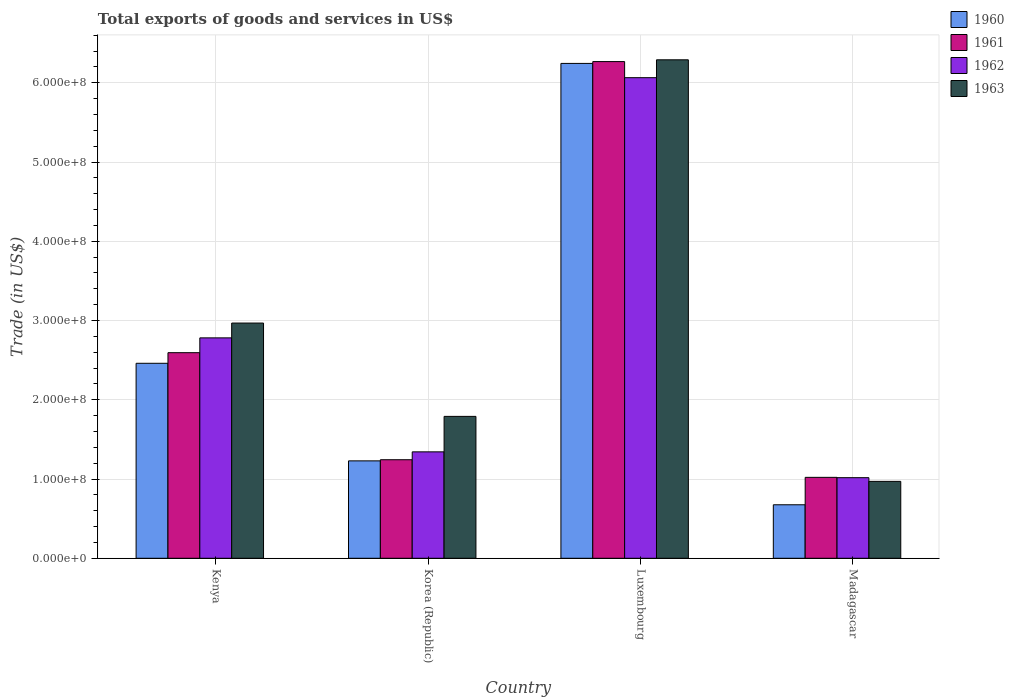How many groups of bars are there?
Ensure brevity in your answer.  4. Are the number of bars on each tick of the X-axis equal?
Make the answer very short. Yes. How many bars are there on the 1st tick from the right?
Provide a short and direct response. 4. What is the label of the 1st group of bars from the left?
Your answer should be very brief. Kenya. In how many cases, is the number of bars for a given country not equal to the number of legend labels?
Make the answer very short. 0. What is the total exports of goods and services in 1960 in Madagascar?
Ensure brevity in your answer.  6.75e+07. Across all countries, what is the maximum total exports of goods and services in 1962?
Provide a short and direct response. 6.06e+08. Across all countries, what is the minimum total exports of goods and services in 1960?
Provide a short and direct response. 6.75e+07. In which country was the total exports of goods and services in 1963 maximum?
Provide a succinct answer. Luxembourg. In which country was the total exports of goods and services in 1963 minimum?
Your answer should be very brief. Madagascar. What is the total total exports of goods and services in 1960 in the graph?
Give a very brief answer. 1.06e+09. What is the difference between the total exports of goods and services in 1962 in Korea (Republic) and that in Luxembourg?
Offer a very short reply. -4.72e+08. What is the difference between the total exports of goods and services in 1961 in Luxembourg and the total exports of goods and services in 1963 in Korea (Republic)?
Make the answer very short. 4.48e+08. What is the average total exports of goods and services in 1963 per country?
Give a very brief answer. 3.00e+08. What is the difference between the total exports of goods and services of/in 1963 and total exports of goods and services of/in 1962 in Madagascar?
Provide a short and direct response. -4.64e+06. In how many countries, is the total exports of goods and services in 1960 greater than 400000000 US$?
Provide a succinct answer. 1. What is the ratio of the total exports of goods and services in 1962 in Kenya to that in Madagascar?
Offer a very short reply. 2.74. Is the total exports of goods and services in 1961 in Kenya less than that in Madagascar?
Ensure brevity in your answer.  No. What is the difference between the highest and the second highest total exports of goods and services in 1961?
Give a very brief answer. 1.35e+08. What is the difference between the highest and the lowest total exports of goods and services in 1961?
Your answer should be very brief. 5.25e+08. In how many countries, is the total exports of goods and services in 1963 greater than the average total exports of goods and services in 1963 taken over all countries?
Provide a short and direct response. 1. Is it the case that in every country, the sum of the total exports of goods and services in 1962 and total exports of goods and services in 1960 is greater than the sum of total exports of goods and services in 1963 and total exports of goods and services in 1961?
Keep it short and to the point. No. What does the 3rd bar from the left in Kenya represents?
Provide a succinct answer. 1962. What does the 2nd bar from the right in Luxembourg represents?
Provide a succinct answer. 1962. Is it the case that in every country, the sum of the total exports of goods and services in 1962 and total exports of goods and services in 1963 is greater than the total exports of goods and services in 1960?
Make the answer very short. Yes. How many bars are there?
Ensure brevity in your answer.  16. Are all the bars in the graph horizontal?
Provide a succinct answer. No. Does the graph contain any zero values?
Your answer should be very brief. No. How many legend labels are there?
Ensure brevity in your answer.  4. How are the legend labels stacked?
Your response must be concise. Vertical. What is the title of the graph?
Provide a short and direct response. Total exports of goods and services in US$. What is the label or title of the X-axis?
Keep it short and to the point. Country. What is the label or title of the Y-axis?
Offer a terse response. Trade (in US$). What is the Trade (in US$) of 1960 in Kenya?
Provide a succinct answer. 2.46e+08. What is the Trade (in US$) of 1961 in Kenya?
Give a very brief answer. 2.59e+08. What is the Trade (in US$) in 1962 in Kenya?
Provide a succinct answer. 2.78e+08. What is the Trade (in US$) in 1963 in Kenya?
Your answer should be compact. 2.97e+08. What is the Trade (in US$) in 1960 in Korea (Republic)?
Give a very brief answer. 1.23e+08. What is the Trade (in US$) in 1961 in Korea (Republic)?
Your answer should be very brief. 1.24e+08. What is the Trade (in US$) of 1962 in Korea (Republic)?
Keep it short and to the point. 1.34e+08. What is the Trade (in US$) of 1963 in Korea (Republic)?
Ensure brevity in your answer.  1.79e+08. What is the Trade (in US$) of 1960 in Luxembourg?
Give a very brief answer. 6.24e+08. What is the Trade (in US$) of 1961 in Luxembourg?
Give a very brief answer. 6.27e+08. What is the Trade (in US$) in 1962 in Luxembourg?
Your response must be concise. 6.06e+08. What is the Trade (in US$) of 1963 in Luxembourg?
Keep it short and to the point. 6.29e+08. What is the Trade (in US$) in 1960 in Madagascar?
Your answer should be compact. 6.75e+07. What is the Trade (in US$) of 1961 in Madagascar?
Your answer should be compact. 1.02e+08. What is the Trade (in US$) of 1962 in Madagascar?
Offer a very short reply. 1.02e+08. What is the Trade (in US$) in 1963 in Madagascar?
Your answer should be very brief. 9.70e+07. Across all countries, what is the maximum Trade (in US$) in 1960?
Offer a very short reply. 6.24e+08. Across all countries, what is the maximum Trade (in US$) in 1961?
Your response must be concise. 6.27e+08. Across all countries, what is the maximum Trade (in US$) of 1962?
Provide a succinct answer. 6.06e+08. Across all countries, what is the maximum Trade (in US$) of 1963?
Offer a very short reply. 6.29e+08. Across all countries, what is the minimum Trade (in US$) of 1960?
Offer a terse response. 6.75e+07. Across all countries, what is the minimum Trade (in US$) of 1961?
Your answer should be compact. 1.02e+08. Across all countries, what is the minimum Trade (in US$) of 1962?
Offer a terse response. 1.02e+08. Across all countries, what is the minimum Trade (in US$) of 1963?
Offer a very short reply. 9.70e+07. What is the total Trade (in US$) in 1960 in the graph?
Ensure brevity in your answer.  1.06e+09. What is the total Trade (in US$) of 1961 in the graph?
Provide a short and direct response. 1.11e+09. What is the total Trade (in US$) in 1962 in the graph?
Provide a succinct answer. 1.12e+09. What is the total Trade (in US$) in 1963 in the graph?
Your response must be concise. 1.20e+09. What is the difference between the Trade (in US$) of 1960 in Kenya and that in Korea (Republic)?
Offer a very short reply. 1.23e+08. What is the difference between the Trade (in US$) in 1961 in Kenya and that in Korea (Republic)?
Your answer should be very brief. 1.35e+08. What is the difference between the Trade (in US$) in 1962 in Kenya and that in Korea (Republic)?
Provide a short and direct response. 1.44e+08. What is the difference between the Trade (in US$) of 1963 in Kenya and that in Korea (Republic)?
Your answer should be very brief. 1.18e+08. What is the difference between the Trade (in US$) of 1960 in Kenya and that in Luxembourg?
Provide a short and direct response. -3.78e+08. What is the difference between the Trade (in US$) of 1961 in Kenya and that in Luxembourg?
Make the answer very short. -3.67e+08. What is the difference between the Trade (in US$) of 1962 in Kenya and that in Luxembourg?
Keep it short and to the point. -3.28e+08. What is the difference between the Trade (in US$) of 1963 in Kenya and that in Luxembourg?
Your answer should be very brief. -3.32e+08. What is the difference between the Trade (in US$) of 1960 in Kenya and that in Madagascar?
Make the answer very short. 1.79e+08. What is the difference between the Trade (in US$) in 1961 in Kenya and that in Madagascar?
Ensure brevity in your answer.  1.57e+08. What is the difference between the Trade (in US$) of 1962 in Kenya and that in Madagascar?
Give a very brief answer. 1.76e+08. What is the difference between the Trade (in US$) of 1963 in Kenya and that in Madagascar?
Your response must be concise. 2.00e+08. What is the difference between the Trade (in US$) in 1960 in Korea (Republic) and that in Luxembourg?
Make the answer very short. -5.02e+08. What is the difference between the Trade (in US$) in 1961 in Korea (Republic) and that in Luxembourg?
Your answer should be very brief. -5.02e+08. What is the difference between the Trade (in US$) of 1962 in Korea (Republic) and that in Luxembourg?
Your response must be concise. -4.72e+08. What is the difference between the Trade (in US$) of 1963 in Korea (Republic) and that in Luxembourg?
Offer a very short reply. -4.50e+08. What is the difference between the Trade (in US$) in 1960 in Korea (Republic) and that in Madagascar?
Ensure brevity in your answer.  5.54e+07. What is the difference between the Trade (in US$) in 1961 in Korea (Republic) and that in Madagascar?
Your answer should be compact. 2.22e+07. What is the difference between the Trade (in US$) of 1962 in Korea (Republic) and that in Madagascar?
Your answer should be compact. 3.26e+07. What is the difference between the Trade (in US$) of 1963 in Korea (Republic) and that in Madagascar?
Provide a succinct answer. 8.20e+07. What is the difference between the Trade (in US$) in 1960 in Luxembourg and that in Madagascar?
Keep it short and to the point. 5.57e+08. What is the difference between the Trade (in US$) in 1961 in Luxembourg and that in Madagascar?
Provide a succinct answer. 5.25e+08. What is the difference between the Trade (in US$) of 1962 in Luxembourg and that in Madagascar?
Provide a succinct answer. 5.05e+08. What is the difference between the Trade (in US$) in 1963 in Luxembourg and that in Madagascar?
Provide a short and direct response. 5.32e+08. What is the difference between the Trade (in US$) of 1960 in Kenya and the Trade (in US$) of 1961 in Korea (Republic)?
Your answer should be compact. 1.22e+08. What is the difference between the Trade (in US$) in 1960 in Kenya and the Trade (in US$) in 1962 in Korea (Republic)?
Offer a very short reply. 1.12e+08. What is the difference between the Trade (in US$) in 1960 in Kenya and the Trade (in US$) in 1963 in Korea (Republic)?
Offer a very short reply. 6.70e+07. What is the difference between the Trade (in US$) in 1961 in Kenya and the Trade (in US$) in 1962 in Korea (Republic)?
Your answer should be very brief. 1.25e+08. What is the difference between the Trade (in US$) of 1961 in Kenya and the Trade (in US$) of 1963 in Korea (Republic)?
Provide a succinct answer. 8.04e+07. What is the difference between the Trade (in US$) in 1962 in Kenya and the Trade (in US$) in 1963 in Korea (Republic)?
Your answer should be very brief. 9.91e+07. What is the difference between the Trade (in US$) in 1960 in Kenya and the Trade (in US$) in 1961 in Luxembourg?
Provide a short and direct response. -3.81e+08. What is the difference between the Trade (in US$) in 1960 in Kenya and the Trade (in US$) in 1962 in Luxembourg?
Your response must be concise. -3.60e+08. What is the difference between the Trade (in US$) of 1960 in Kenya and the Trade (in US$) of 1963 in Luxembourg?
Your response must be concise. -3.83e+08. What is the difference between the Trade (in US$) in 1961 in Kenya and the Trade (in US$) in 1962 in Luxembourg?
Keep it short and to the point. -3.47e+08. What is the difference between the Trade (in US$) of 1961 in Kenya and the Trade (in US$) of 1963 in Luxembourg?
Your answer should be very brief. -3.70e+08. What is the difference between the Trade (in US$) of 1962 in Kenya and the Trade (in US$) of 1963 in Luxembourg?
Your answer should be compact. -3.51e+08. What is the difference between the Trade (in US$) in 1960 in Kenya and the Trade (in US$) in 1961 in Madagascar?
Make the answer very short. 1.44e+08. What is the difference between the Trade (in US$) of 1960 in Kenya and the Trade (in US$) of 1962 in Madagascar?
Offer a terse response. 1.44e+08. What is the difference between the Trade (in US$) of 1960 in Kenya and the Trade (in US$) of 1963 in Madagascar?
Provide a short and direct response. 1.49e+08. What is the difference between the Trade (in US$) of 1961 in Kenya and the Trade (in US$) of 1962 in Madagascar?
Keep it short and to the point. 1.58e+08. What is the difference between the Trade (in US$) in 1961 in Kenya and the Trade (in US$) in 1963 in Madagascar?
Make the answer very short. 1.62e+08. What is the difference between the Trade (in US$) in 1962 in Kenya and the Trade (in US$) in 1963 in Madagascar?
Your answer should be very brief. 1.81e+08. What is the difference between the Trade (in US$) of 1960 in Korea (Republic) and the Trade (in US$) of 1961 in Luxembourg?
Your answer should be compact. -5.04e+08. What is the difference between the Trade (in US$) in 1960 in Korea (Republic) and the Trade (in US$) in 1962 in Luxembourg?
Give a very brief answer. -4.84e+08. What is the difference between the Trade (in US$) in 1960 in Korea (Republic) and the Trade (in US$) in 1963 in Luxembourg?
Make the answer very short. -5.06e+08. What is the difference between the Trade (in US$) of 1961 in Korea (Republic) and the Trade (in US$) of 1962 in Luxembourg?
Your response must be concise. -4.82e+08. What is the difference between the Trade (in US$) of 1961 in Korea (Republic) and the Trade (in US$) of 1963 in Luxembourg?
Ensure brevity in your answer.  -5.05e+08. What is the difference between the Trade (in US$) in 1962 in Korea (Republic) and the Trade (in US$) in 1963 in Luxembourg?
Provide a short and direct response. -4.95e+08. What is the difference between the Trade (in US$) in 1960 in Korea (Republic) and the Trade (in US$) in 1961 in Madagascar?
Make the answer very short. 2.08e+07. What is the difference between the Trade (in US$) of 1960 in Korea (Republic) and the Trade (in US$) of 1962 in Madagascar?
Provide a succinct answer. 2.12e+07. What is the difference between the Trade (in US$) of 1960 in Korea (Republic) and the Trade (in US$) of 1963 in Madagascar?
Offer a very short reply. 2.59e+07. What is the difference between the Trade (in US$) in 1961 in Korea (Republic) and the Trade (in US$) in 1962 in Madagascar?
Ensure brevity in your answer.  2.27e+07. What is the difference between the Trade (in US$) in 1961 in Korea (Republic) and the Trade (in US$) in 1963 in Madagascar?
Your answer should be very brief. 2.73e+07. What is the difference between the Trade (in US$) in 1962 in Korea (Republic) and the Trade (in US$) in 1963 in Madagascar?
Offer a terse response. 3.72e+07. What is the difference between the Trade (in US$) of 1960 in Luxembourg and the Trade (in US$) of 1961 in Madagascar?
Ensure brevity in your answer.  5.22e+08. What is the difference between the Trade (in US$) of 1960 in Luxembourg and the Trade (in US$) of 1962 in Madagascar?
Make the answer very short. 5.23e+08. What is the difference between the Trade (in US$) in 1960 in Luxembourg and the Trade (in US$) in 1963 in Madagascar?
Your answer should be compact. 5.27e+08. What is the difference between the Trade (in US$) in 1961 in Luxembourg and the Trade (in US$) in 1962 in Madagascar?
Offer a very short reply. 5.25e+08. What is the difference between the Trade (in US$) of 1961 in Luxembourg and the Trade (in US$) of 1963 in Madagascar?
Provide a short and direct response. 5.30e+08. What is the difference between the Trade (in US$) in 1962 in Luxembourg and the Trade (in US$) in 1963 in Madagascar?
Your response must be concise. 5.09e+08. What is the average Trade (in US$) in 1960 per country?
Give a very brief answer. 2.65e+08. What is the average Trade (in US$) of 1961 per country?
Make the answer very short. 2.78e+08. What is the average Trade (in US$) of 1962 per country?
Make the answer very short. 2.80e+08. What is the average Trade (in US$) of 1963 per country?
Ensure brevity in your answer.  3.00e+08. What is the difference between the Trade (in US$) of 1960 and Trade (in US$) of 1961 in Kenya?
Your response must be concise. -1.34e+07. What is the difference between the Trade (in US$) in 1960 and Trade (in US$) in 1962 in Kenya?
Provide a succinct answer. -3.21e+07. What is the difference between the Trade (in US$) in 1960 and Trade (in US$) in 1963 in Kenya?
Your response must be concise. -5.08e+07. What is the difference between the Trade (in US$) in 1961 and Trade (in US$) in 1962 in Kenya?
Ensure brevity in your answer.  -1.87e+07. What is the difference between the Trade (in US$) of 1961 and Trade (in US$) of 1963 in Kenya?
Offer a terse response. -3.74e+07. What is the difference between the Trade (in US$) of 1962 and Trade (in US$) of 1963 in Kenya?
Ensure brevity in your answer.  -1.87e+07. What is the difference between the Trade (in US$) of 1960 and Trade (in US$) of 1961 in Korea (Republic)?
Keep it short and to the point. -1.44e+06. What is the difference between the Trade (in US$) of 1960 and Trade (in US$) of 1962 in Korea (Republic)?
Your response must be concise. -1.14e+07. What is the difference between the Trade (in US$) in 1960 and Trade (in US$) in 1963 in Korea (Republic)?
Offer a very short reply. -5.61e+07. What is the difference between the Trade (in US$) in 1961 and Trade (in US$) in 1962 in Korea (Republic)?
Offer a terse response. -9.94e+06. What is the difference between the Trade (in US$) of 1961 and Trade (in US$) of 1963 in Korea (Republic)?
Give a very brief answer. -5.47e+07. What is the difference between the Trade (in US$) of 1962 and Trade (in US$) of 1963 in Korea (Republic)?
Provide a succinct answer. -4.48e+07. What is the difference between the Trade (in US$) of 1960 and Trade (in US$) of 1961 in Luxembourg?
Your response must be concise. -2.31e+06. What is the difference between the Trade (in US$) of 1960 and Trade (in US$) of 1962 in Luxembourg?
Provide a short and direct response. 1.80e+07. What is the difference between the Trade (in US$) of 1960 and Trade (in US$) of 1963 in Luxembourg?
Keep it short and to the point. -4.56e+06. What is the difference between the Trade (in US$) of 1961 and Trade (in US$) of 1962 in Luxembourg?
Provide a short and direct response. 2.03e+07. What is the difference between the Trade (in US$) of 1961 and Trade (in US$) of 1963 in Luxembourg?
Keep it short and to the point. -2.25e+06. What is the difference between the Trade (in US$) of 1962 and Trade (in US$) of 1963 in Luxembourg?
Ensure brevity in your answer.  -2.26e+07. What is the difference between the Trade (in US$) in 1960 and Trade (in US$) in 1961 in Madagascar?
Your response must be concise. -3.46e+07. What is the difference between the Trade (in US$) in 1960 and Trade (in US$) in 1962 in Madagascar?
Make the answer very short. -3.42e+07. What is the difference between the Trade (in US$) of 1960 and Trade (in US$) of 1963 in Madagascar?
Provide a short and direct response. -2.95e+07. What is the difference between the Trade (in US$) in 1961 and Trade (in US$) in 1962 in Madagascar?
Offer a very short reply. 4.22e+05. What is the difference between the Trade (in US$) of 1961 and Trade (in US$) of 1963 in Madagascar?
Make the answer very short. 5.06e+06. What is the difference between the Trade (in US$) in 1962 and Trade (in US$) in 1963 in Madagascar?
Provide a short and direct response. 4.64e+06. What is the ratio of the Trade (in US$) in 1960 in Kenya to that in Korea (Republic)?
Offer a very short reply. 2. What is the ratio of the Trade (in US$) in 1961 in Kenya to that in Korea (Republic)?
Your answer should be compact. 2.09. What is the ratio of the Trade (in US$) in 1962 in Kenya to that in Korea (Republic)?
Give a very brief answer. 2.07. What is the ratio of the Trade (in US$) of 1963 in Kenya to that in Korea (Republic)?
Give a very brief answer. 1.66. What is the ratio of the Trade (in US$) in 1960 in Kenya to that in Luxembourg?
Offer a terse response. 0.39. What is the ratio of the Trade (in US$) of 1961 in Kenya to that in Luxembourg?
Your answer should be compact. 0.41. What is the ratio of the Trade (in US$) in 1962 in Kenya to that in Luxembourg?
Offer a terse response. 0.46. What is the ratio of the Trade (in US$) in 1963 in Kenya to that in Luxembourg?
Your response must be concise. 0.47. What is the ratio of the Trade (in US$) in 1960 in Kenya to that in Madagascar?
Give a very brief answer. 3.64. What is the ratio of the Trade (in US$) in 1961 in Kenya to that in Madagascar?
Your answer should be very brief. 2.54. What is the ratio of the Trade (in US$) of 1962 in Kenya to that in Madagascar?
Give a very brief answer. 2.73. What is the ratio of the Trade (in US$) in 1963 in Kenya to that in Madagascar?
Offer a very short reply. 3.06. What is the ratio of the Trade (in US$) of 1960 in Korea (Republic) to that in Luxembourg?
Give a very brief answer. 0.2. What is the ratio of the Trade (in US$) in 1961 in Korea (Republic) to that in Luxembourg?
Offer a terse response. 0.2. What is the ratio of the Trade (in US$) of 1962 in Korea (Republic) to that in Luxembourg?
Keep it short and to the point. 0.22. What is the ratio of the Trade (in US$) in 1963 in Korea (Republic) to that in Luxembourg?
Your answer should be very brief. 0.28. What is the ratio of the Trade (in US$) of 1960 in Korea (Republic) to that in Madagascar?
Ensure brevity in your answer.  1.82. What is the ratio of the Trade (in US$) of 1961 in Korea (Republic) to that in Madagascar?
Offer a very short reply. 1.22. What is the ratio of the Trade (in US$) of 1962 in Korea (Republic) to that in Madagascar?
Your answer should be compact. 1.32. What is the ratio of the Trade (in US$) of 1963 in Korea (Republic) to that in Madagascar?
Make the answer very short. 1.84. What is the ratio of the Trade (in US$) of 1960 in Luxembourg to that in Madagascar?
Ensure brevity in your answer.  9.25. What is the ratio of the Trade (in US$) of 1961 in Luxembourg to that in Madagascar?
Make the answer very short. 6.14. What is the ratio of the Trade (in US$) in 1962 in Luxembourg to that in Madagascar?
Make the answer very short. 5.96. What is the ratio of the Trade (in US$) of 1963 in Luxembourg to that in Madagascar?
Provide a short and direct response. 6.48. What is the difference between the highest and the second highest Trade (in US$) of 1960?
Give a very brief answer. 3.78e+08. What is the difference between the highest and the second highest Trade (in US$) in 1961?
Your answer should be compact. 3.67e+08. What is the difference between the highest and the second highest Trade (in US$) of 1962?
Make the answer very short. 3.28e+08. What is the difference between the highest and the second highest Trade (in US$) in 1963?
Give a very brief answer. 3.32e+08. What is the difference between the highest and the lowest Trade (in US$) of 1960?
Provide a succinct answer. 5.57e+08. What is the difference between the highest and the lowest Trade (in US$) of 1961?
Keep it short and to the point. 5.25e+08. What is the difference between the highest and the lowest Trade (in US$) of 1962?
Make the answer very short. 5.05e+08. What is the difference between the highest and the lowest Trade (in US$) in 1963?
Provide a succinct answer. 5.32e+08. 